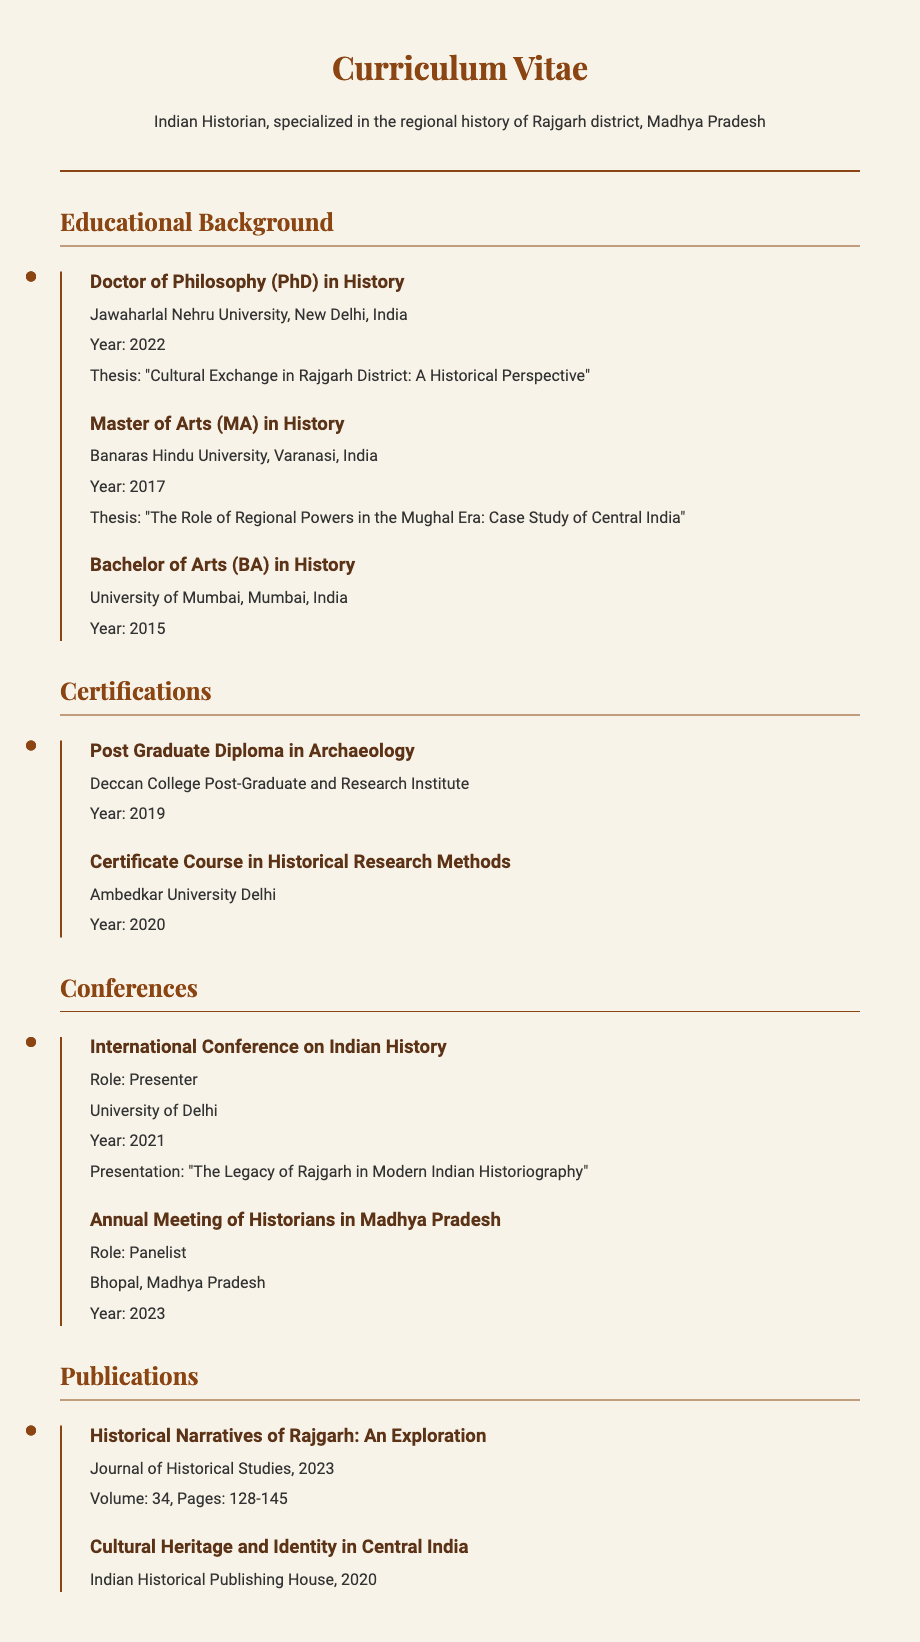What is the highest degree obtained? The highest degree mentioned in the document is the Doctor of Philosophy (PhD) in History.
Answer: Doctor of Philosophy (PhD) What was the thesis topic for the PhD? The thesis topic for the PhD is provided in the document as "Cultural Exchange in Rajgarh District: A Historical Perspective".
Answer: Cultural Exchange in Rajgarh District: A Historical Perspective Which university awarded the Master's degree? The university that awarded the Master of Arts (MA) in History is mentioned in the document as Banaras Hindu University.
Answer: Banaras Hindu University What year was the BA degree completed? The year when the Bachelor of Arts (BA) in History was completed is stated as 2015.
Answer: 2015 How many certifications are listed? The total number of certifications listed in the document needs to be counted. There are two certifications detailed.
Answer: 2 What is the title of the presentation made at the International Conference? The title of the presentation made at the International Conference on Indian History is specified in the document as "The Legacy of Rajgarh in Modern Indian Historiography".
Answer: The Legacy of Rajgarh in Modern Indian Historiography Where did the presenter receive a Post Graduate Diploma? The place where the Post Graduate Diploma in Archaeology was obtained is stated as Deccan College Post-Graduate and Research Institute.
Answer: Deccan College Post-Graduate and Research Institute What was the topic of the MA thesis? The topic of the Master of Arts (MA) thesis is provided as "The Role of Regional Powers in the Mughal Era: Case Study of Central India".
Answer: The Role of Regional Powers in the Mughal Era: Case Study of Central India 